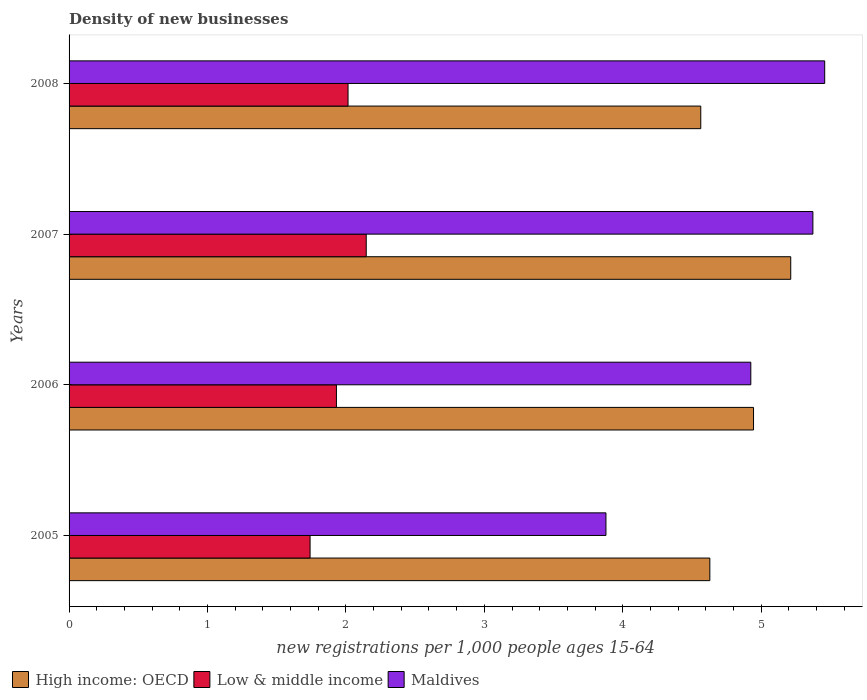How many different coloured bars are there?
Your response must be concise. 3. How many groups of bars are there?
Keep it short and to the point. 4. Are the number of bars on each tick of the Y-axis equal?
Provide a succinct answer. Yes. What is the number of new registrations in High income: OECD in 2005?
Your response must be concise. 4.63. Across all years, what is the maximum number of new registrations in Maldives?
Provide a succinct answer. 5.46. Across all years, what is the minimum number of new registrations in High income: OECD?
Your answer should be compact. 4.56. In which year was the number of new registrations in Low & middle income minimum?
Provide a short and direct response. 2005. What is the total number of new registrations in Low & middle income in the graph?
Give a very brief answer. 7.83. What is the difference between the number of new registrations in High income: OECD in 2005 and that in 2008?
Your response must be concise. 0.07. What is the difference between the number of new registrations in High income: OECD in 2008 and the number of new registrations in Maldives in 2007?
Offer a very short reply. -0.81. What is the average number of new registrations in High income: OECD per year?
Make the answer very short. 4.84. In the year 2005, what is the difference between the number of new registrations in Low & middle income and number of new registrations in High income: OECD?
Offer a very short reply. -2.89. What is the ratio of the number of new registrations in High income: OECD in 2005 to that in 2008?
Make the answer very short. 1.01. Is the number of new registrations in Low & middle income in 2005 less than that in 2008?
Your answer should be very brief. Yes. Is the difference between the number of new registrations in Low & middle income in 2006 and 2007 greater than the difference between the number of new registrations in High income: OECD in 2006 and 2007?
Your response must be concise. Yes. What is the difference between the highest and the second highest number of new registrations in High income: OECD?
Make the answer very short. 0.27. What is the difference between the highest and the lowest number of new registrations in High income: OECD?
Make the answer very short. 0.65. Is the sum of the number of new registrations in Low & middle income in 2006 and 2008 greater than the maximum number of new registrations in Maldives across all years?
Your answer should be compact. No. What does the 1st bar from the top in 2008 represents?
Offer a very short reply. Maldives. What does the 1st bar from the bottom in 2006 represents?
Keep it short and to the point. High income: OECD. Is it the case that in every year, the sum of the number of new registrations in Maldives and number of new registrations in Low & middle income is greater than the number of new registrations in High income: OECD?
Your response must be concise. Yes. How many bars are there?
Offer a terse response. 12. Are the values on the major ticks of X-axis written in scientific E-notation?
Make the answer very short. No. Does the graph contain any zero values?
Make the answer very short. No. Does the graph contain grids?
Your answer should be very brief. No. Where does the legend appear in the graph?
Your response must be concise. Bottom left. How many legend labels are there?
Make the answer very short. 3. What is the title of the graph?
Ensure brevity in your answer.  Density of new businesses. Does "Portugal" appear as one of the legend labels in the graph?
Offer a very short reply. No. What is the label or title of the X-axis?
Your response must be concise. New registrations per 1,0 people ages 15-64. What is the label or title of the Y-axis?
Your answer should be very brief. Years. What is the new registrations per 1,000 people ages 15-64 in High income: OECD in 2005?
Provide a succinct answer. 4.63. What is the new registrations per 1,000 people ages 15-64 in Low & middle income in 2005?
Ensure brevity in your answer.  1.74. What is the new registrations per 1,000 people ages 15-64 in Maldives in 2005?
Provide a succinct answer. 3.88. What is the new registrations per 1,000 people ages 15-64 in High income: OECD in 2006?
Keep it short and to the point. 4.94. What is the new registrations per 1,000 people ages 15-64 of Low & middle income in 2006?
Your answer should be very brief. 1.93. What is the new registrations per 1,000 people ages 15-64 in Maldives in 2006?
Keep it short and to the point. 4.93. What is the new registrations per 1,000 people ages 15-64 of High income: OECD in 2007?
Your answer should be compact. 5.21. What is the new registrations per 1,000 people ages 15-64 of Low & middle income in 2007?
Ensure brevity in your answer.  2.15. What is the new registrations per 1,000 people ages 15-64 in Maldives in 2007?
Give a very brief answer. 5.37. What is the new registrations per 1,000 people ages 15-64 of High income: OECD in 2008?
Provide a short and direct response. 4.56. What is the new registrations per 1,000 people ages 15-64 of Low & middle income in 2008?
Give a very brief answer. 2.02. What is the new registrations per 1,000 people ages 15-64 in Maldives in 2008?
Ensure brevity in your answer.  5.46. Across all years, what is the maximum new registrations per 1,000 people ages 15-64 of High income: OECD?
Provide a short and direct response. 5.21. Across all years, what is the maximum new registrations per 1,000 people ages 15-64 of Low & middle income?
Offer a very short reply. 2.15. Across all years, what is the maximum new registrations per 1,000 people ages 15-64 in Maldives?
Provide a succinct answer. 5.46. Across all years, what is the minimum new registrations per 1,000 people ages 15-64 of High income: OECD?
Provide a succinct answer. 4.56. Across all years, what is the minimum new registrations per 1,000 people ages 15-64 of Low & middle income?
Make the answer very short. 1.74. Across all years, what is the minimum new registrations per 1,000 people ages 15-64 in Maldives?
Your response must be concise. 3.88. What is the total new registrations per 1,000 people ages 15-64 in High income: OECD in the graph?
Keep it short and to the point. 19.35. What is the total new registrations per 1,000 people ages 15-64 in Low & middle income in the graph?
Provide a short and direct response. 7.83. What is the total new registrations per 1,000 people ages 15-64 of Maldives in the graph?
Your response must be concise. 19.64. What is the difference between the new registrations per 1,000 people ages 15-64 of High income: OECD in 2005 and that in 2006?
Provide a short and direct response. -0.32. What is the difference between the new registrations per 1,000 people ages 15-64 in Low & middle income in 2005 and that in 2006?
Your answer should be compact. -0.19. What is the difference between the new registrations per 1,000 people ages 15-64 of Maldives in 2005 and that in 2006?
Make the answer very short. -1.05. What is the difference between the new registrations per 1,000 people ages 15-64 in High income: OECD in 2005 and that in 2007?
Provide a succinct answer. -0.58. What is the difference between the new registrations per 1,000 people ages 15-64 of Low & middle income in 2005 and that in 2007?
Offer a terse response. -0.41. What is the difference between the new registrations per 1,000 people ages 15-64 in Maldives in 2005 and that in 2007?
Your response must be concise. -1.5. What is the difference between the new registrations per 1,000 people ages 15-64 in High income: OECD in 2005 and that in 2008?
Offer a terse response. 0.07. What is the difference between the new registrations per 1,000 people ages 15-64 of Low & middle income in 2005 and that in 2008?
Provide a short and direct response. -0.27. What is the difference between the new registrations per 1,000 people ages 15-64 of Maldives in 2005 and that in 2008?
Your answer should be compact. -1.58. What is the difference between the new registrations per 1,000 people ages 15-64 in High income: OECD in 2006 and that in 2007?
Ensure brevity in your answer.  -0.27. What is the difference between the new registrations per 1,000 people ages 15-64 in Low & middle income in 2006 and that in 2007?
Your answer should be very brief. -0.22. What is the difference between the new registrations per 1,000 people ages 15-64 in Maldives in 2006 and that in 2007?
Your response must be concise. -0.45. What is the difference between the new registrations per 1,000 people ages 15-64 in High income: OECD in 2006 and that in 2008?
Your answer should be compact. 0.38. What is the difference between the new registrations per 1,000 people ages 15-64 in Low & middle income in 2006 and that in 2008?
Give a very brief answer. -0.08. What is the difference between the new registrations per 1,000 people ages 15-64 in Maldives in 2006 and that in 2008?
Keep it short and to the point. -0.53. What is the difference between the new registrations per 1,000 people ages 15-64 in High income: OECD in 2007 and that in 2008?
Provide a short and direct response. 0.65. What is the difference between the new registrations per 1,000 people ages 15-64 of Low & middle income in 2007 and that in 2008?
Offer a terse response. 0.13. What is the difference between the new registrations per 1,000 people ages 15-64 in Maldives in 2007 and that in 2008?
Your answer should be very brief. -0.09. What is the difference between the new registrations per 1,000 people ages 15-64 of High income: OECD in 2005 and the new registrations per 1,000 people ages 15-64 of Low & middle income in 2006?
Make the answer very short. 2.7. What is the difference between the new registrations per 1,000 people ages 15-64 in High income: OECD in 2005 and the new registrations per 1,000 people ages 15-64 in Maldives in 2006?
Give a very brief answer. -0.3. What is the difference between the new registrations per 1,000 people ages 15-64 in Low & middle income in 2005 and the new registrations per 1,000 people ages 15-64 in Maldives in 2006?
Your answer should be compact. -3.18. What is the difference between the new registrations per 1,000 people ages 15-64 of High income: OECD in 2005 and the new registrations per 1,000 people ages 15-64 of Low & middle income in 2007?
Offer a terse response. 2.48. What is the difference between the new registrations per 1,000 people ages 15-64 of High income: OECD in 2005 and the new registrations per 1,000 people ages 15-64 of Maldives in 2007?
Ensure brevity in your answer.  -0.74. What is the difference between the new registrations per 1,000 people ages 15-64 in Low & middle income in 2005 and the new registrations per 1,000 people ages 15-64 in Maldives in 2007?
Your answer should be compact. -3.63. What is the difference between the new registrations per 1,000 people ages 15-64 of High income: OECD in 2005 and the new registrations per 1,000 people ages 15-64 of Low & middle income in 2008?
Give a very brief answer. 2.61. What is the difference between the new registrations per 1,000 people ages 15-64 in High income: OECD in 2005 and the new registrations per 1,000 people ages 15-64 in Maldives in 2008?
Offer a terse response. -0.83. What is the difference between the new registrations per 1,000 people ages 15-64 in Low & middle income in 2005 and the new registrations per 1,000 people ages 15-64 in Maldives in 2008?
Give a very brief answer. -3.72. What is the difference between the new registrations per 1,000 people ages 15-64 in High income: OECD in 2006 and the new registrations per 1,000 people ages 15-64 in Low & middle income in 2007?
Offer a very short reply. 2.8. What is the difference between the new registrations per 1,000 people ages 15-64 of High income: OECD in 2006 and the new registrations per 1,000 people ages 15-64 of Maldives in 2007?
Offer a terse response. -0.43. What is the difference between the new registrations per 1,000 people ages 15-64 of Low & middle income in 2006 and the new registrations per 1,000 people ages 15-64 of Maldives in 2007?
Your answer should be compact. -3.44. What is the difference between the new registrations per 1,000 people ages 15-64 in High income: OECD in 2006 and the new registrations per 1,000 people ages 15-64 in Low & middle income in 2008?
Provide a short and direct response. 2.93. What is the difference between the new registrations per 1,000 people ages 15-64 of High income: OECD in 2006 and the new registrations per 1,000 people ages 15-64 of Maldives in 2008?
Your answer should be compact. -0.51. What is the difference between the new registrations per 1,000 people ages 15-64 in Low & middle income in 2006 and the new registrations per 1,000 people ages 15-64 in Maldives in 2008?
Keep it short and to the point. -3.53. What is the difference between the new registrations per 1,000 people ages 15-64 in High income: OECD in 2007 and the new registrations per 1,000 people ages 15-64 in Low & middle income in 2008?
Ensure brevity in your answer.  3.2. What is the difference between the new registrations per 1,000 people ages 15-64 in High income: OECD in 2007 and the new registrations per 1,000 people ages 15-64 in Maldives in 2008?
Offer a very short reply. -0.25. What is the difference between the new registrations per 1,000 people ages 15-64 of Low & middle income in 2007 and the new registrations per 1,000 people ages 15-64 of Maldives in 2008?
Your answer should be very brief. -3.31. What is the average new registrations per 1,000 people ages 15-64 in High income: OECD per year?
Your answer should be compact. 4.84. What is the average new registrations per 1,000 people ages 15-64 of Low & middle income per year?
Ensure brevity in your answer.  1.96. What is the average new registrations per 1,000 people ages 15-64 of Maldives per year?
Keep it short and to the point. 4.91. In the year 2005, what is the difference between the new registrations per 1,000 people ages 15-64 in High income: OECD and new registrations per 1,000 people ages 15-64 in Low & middle income?
Offer a terse response. 2.89. In the year 2005, what is the difference between the new registrations per 1,000 people ages 15-64 of High income: OECD and new registrations per 1,000 people ages 15-64 of Maldives?
Offer a terse response. 0.75. In the year 2005, what is the difference between the new registrations per 1,000 people ages 15-64 of Low & middle income and new registrations per 1,000 people ages 15-64 of Maldives?
Your response must be concise. -2.14. In the year 2006, what is the difference between the new registrations per 1,000 people ages 15-64 in High income: OECD and new registrations per 1,000 people ages 15-64 in Low & middle income?
Offer a very short reply. 3.01. In the year 2006, what is the difference between the new registrations per 1,000 people ages 15-64 of High income: OECD and new registrations per 1,000 people ages 15-64 of Maldives?
Give a very brief answer. 0.02. In the year 2006, what is the difference between the new registrations per 1,000 people ages 15-64 of Low & middle income and new registrations per 1,000 people ages 15-64 of Maldives?
Your response must be concise. -2.99. In the year 2007, what is the difference between the new registrations per 1,000 people ages 15-64 in High income: OECD and new registrations per 1,000 people ages 15-64 in Low & middle income?
Keep it short and to the point. 3.07. In the year 2007, what is the difference between the new registrations per 1,000 people ages 15-64 of High income: OECD and new registrations per 1,000 people ages 15-64 of Maldives?
Offer a terse response. -0.16. In the year 2007, what is the difference between the new registrations per 1,000 people ages 15-64 in Low & middle income and new registrations per 1,000 people ages 15-64 in Maldives?
Give a very brief answer. -3.23. In the year 2008, what is the difference between the new registrations per 1,000 people ages 15-64 in High income: OECD and new registrations per 1,000 people ages 15-64 in Low & middle income?
Your response must be concise. 2.55. In the year 2008, what is the difference between the new registrations per 1,000 people ages 15-64 in High income: OECD and new registrations per 1,000 people ages 15-64 in Maldives?
Ensure brevity in your answer.  -0.9. In the year 2008, what is the difference between the new registrations per 1,000 people ages 15-64 in Low & middle income and new registrations per 1,000 people ages 15-64 in Maldives?
Your response must be concise. -3.44. What is the ratio of the new registrations per 1,000 people ages 15-64 in High income: OECD in 2005 to that in 2006?
Give a very brief answer. 0.94. What is the ratio of the new registrations per 1,000 people ages 15-64 of Low & middle income in 2005 to that in 2006?
Provide a short and direct response. 0.9. What is the ratio of the new registrations per 1,000 people ages 15-64 in Maldives in 2005 to that in 2006?
Your response must be concise. 0.79. What is the ratio of the new registrations per 1,000 people ages 15-64 in High income: OECD in 2005 to that in 2007?
Give a very brief answer. 0.89. What is the ratio of the new registrations per 1,000 people ages 15-64 in Low & middle income in 2005 to that in 2007?
Keep it short and to the point. 0.81. What is the ratio of the new registrations per 1,000 people ages 15-64 in Maldives in 2005 to that in 2007?
Provide a short and direct response. 0.72. What is the ratio of the new registrations per 1,000 people ages 15-64 of High income: OECD in 2005 to that in 2008?
Ensure brevity in your answer.  1.01. What is the ratio of the new registrations per 1,000 people ages 15-64 in Low & middle income in 2005 to that in 2008?
Your response must be concise. 0.86. What is the ratio of the new registrations per 1,000 people ages 15-64 of Maldives in 2005 to that in 2008?
Keep it short and to the point. 0.71. What is the ratio of the new registrations per 1,000 people ages 15-64 of High income: OECD in 2006 to that in 2007?
Ensure brevity in your answer.  0.95. What is the ratio of the new registrations per 1,000 people ages 15-64 of Low & middle income in 2006 to that in 2007?
Your answer should be compact. 0.9. What is the ratio of the new registrations per 1,000 people ages 15-64 of Maldives in 2006 to that in 2007?
Your answer should be very brief. 0.92. What is the ratio of the new registrations per 1,000 people ages 15-64 in High income: OECD in 2006 to that in 2008?
Make the answer very short. 1.08. What is the ratio of the new registrations per 1,000 people ages 15-64 of Low & middle income in 2006 to that in 2008?
Provide a succinct answer. 0.96. What is the ratio of the new registrations per 1,000 people ages 15-64 in Maldives in 2006 to that in 2008?
Provide a succinct answer. 0.9. What is the ratio of the new registrations per 1,000 people ages 15-64 of High income: OECD in 2007 to that in 2008?
Ensure brevity in your answer.  1.14. What is the ratio of the new registrations per 1,000 people ages 15-64 in Low & middle income in 2007 to that in 2008?
Provide a short and direct response. 1.07. What is the ratio of the new registrations per 1,000 people ages 15-64 in Maldives in 2007 to that in 2008?
Offer a terse response. 0.98. What is the difference between the highest and the second highest new registrations per 1,000 people ages 15-64 in High income: OECD?
Give a very brief answer. 0.27. What is the difference between the highest and the second highest new registrations per 1,000 people ages 15-64 in Low & middle income?
Offer a terse response. 0.13. What is the difference between the highest and the second highest new registrations per 1,000 people ages 15-64 of Maldives?
Your answer should be compact. 0.09. What is the difference between the highest and the lowest new registrations per 1,000 people ages 15-64 of High income: OECD?
Provide a succinct answer. 0.65. What is the difference between the highest and the lowest new registrations per 1,000 people ages 15-64 of Low & middle income?
Ensure brevity in your answer.  0.41. What is the difference between the highest and the lowest new registrations per 1,000 people ages 15-64 of Maldives?
Keep it short and to the point. 1.58. 